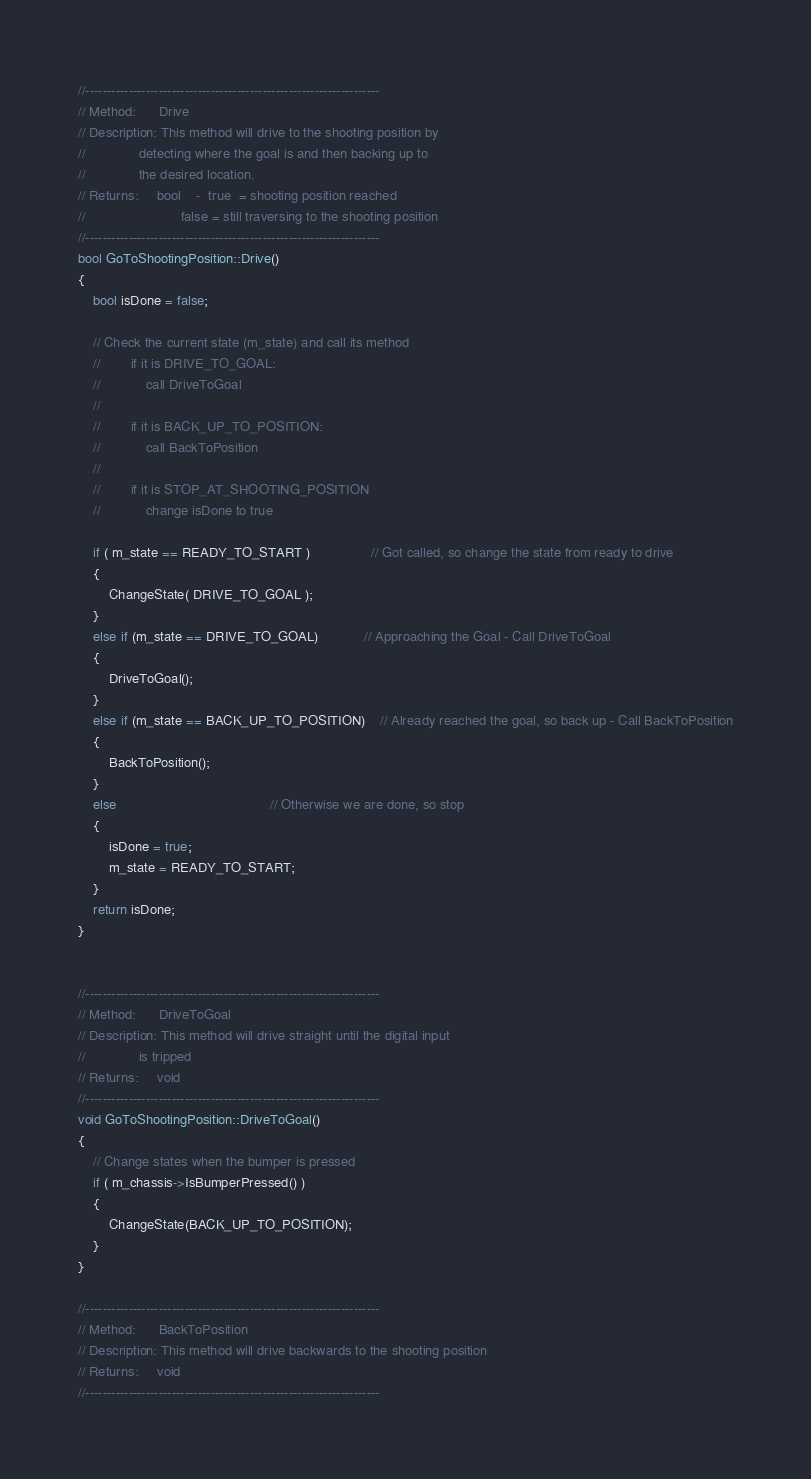<code> <loc_0><loc_0><loc_500><loc_500><_C++_>//--------------------------------------------------------------------
// Method:      Drive
// Description: This method will drive to the shooting position by
//              detecting where the goal is and then backing up to
//              the desired location.
// Returns:     bool    -  true  = shooting position reached
//                         false = still traversing to the shooting position
//--------------------------------------------------------------------
bool GoToShootingPosition::Drive()
{
    bool isDone = false;

    // Check the current state (m_state) and call its method
    //        if it is DRIVE_TO_GOAL:
    //            call DriveToGoal
    //
    //        if it is BACK_UP_TO_POSITION:
    //            call BackToPosition
    //
    //        if it is STOP_AT_SHOOTING_POSITION
    //            change isDone to true

    if ( m_state == READY_TO_START )				// Got called, so change the state from ready to drive
    {
        ChangeState( DRIVE_TO_GOAL );
    }
    else if (m_state == DRIVE_TO_GOAL)			// Approaching the Goal - Call DriveToGoal
	{
		DriveToGoal();
	}
	else if (m_state == BACK_UP_TO_POSITION)	// Already reached the goal, so back up - Call BackToPosition
	{
		BackToPosition();
	}
	else										// Otherwise we are done, so stop
	{
		isDone = true;
		m_state = READY_TO_START;
	}
    return isDone;
}


//--------------------------------------------------------------------
// Method:      DriveToGoal
// Description: This method will drive straight until the digital input
//              is tripped
// Returns:     void
//--------------------------------------------------------------------
void GoToShootingPosition::DriveToGoal()
{
	// Change states when the bumper is pressed
	if ( m_chassis->IsBumperPressed() )
	{
		ChangeState(BACK_UP_TO_POSITION);
	}
}

//--------------------------------------------------------------------
// Method:      BackToPosition
// Description: This method will drive backwards to the shooting position
// Returns:     void
//--------------------------------------------------------------------</code> 